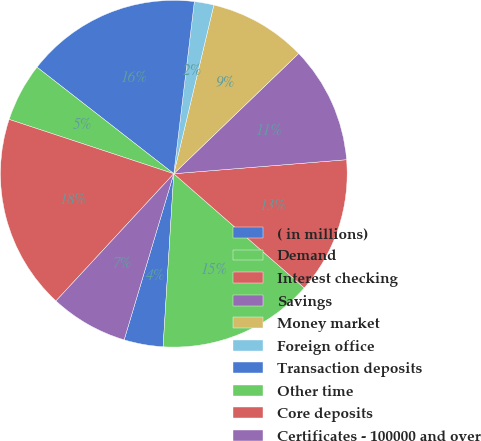Convert chart to OTSL. <chart><loc_0><loc_0><loc_500><loc_500><pie_chart><fcel>( in millions)<fcel>Demand<fcel>Interest checking<fcel>Savings<fcel>Money market<fcel>Foreign office<fcel>Transaction deposits<fcel>Other time<fcel>Core deposits<fcel>Certificates - 100000 and over<nl><fcel>3.64%<fcel>14.54%<fcel>12.73%<fcel>10.91%<fcel>9.09%<fcel>1.82%<fcel>16.36%<fcel>5.46%<fcel>18.18%<fcel>7.27%<nl></chart> 